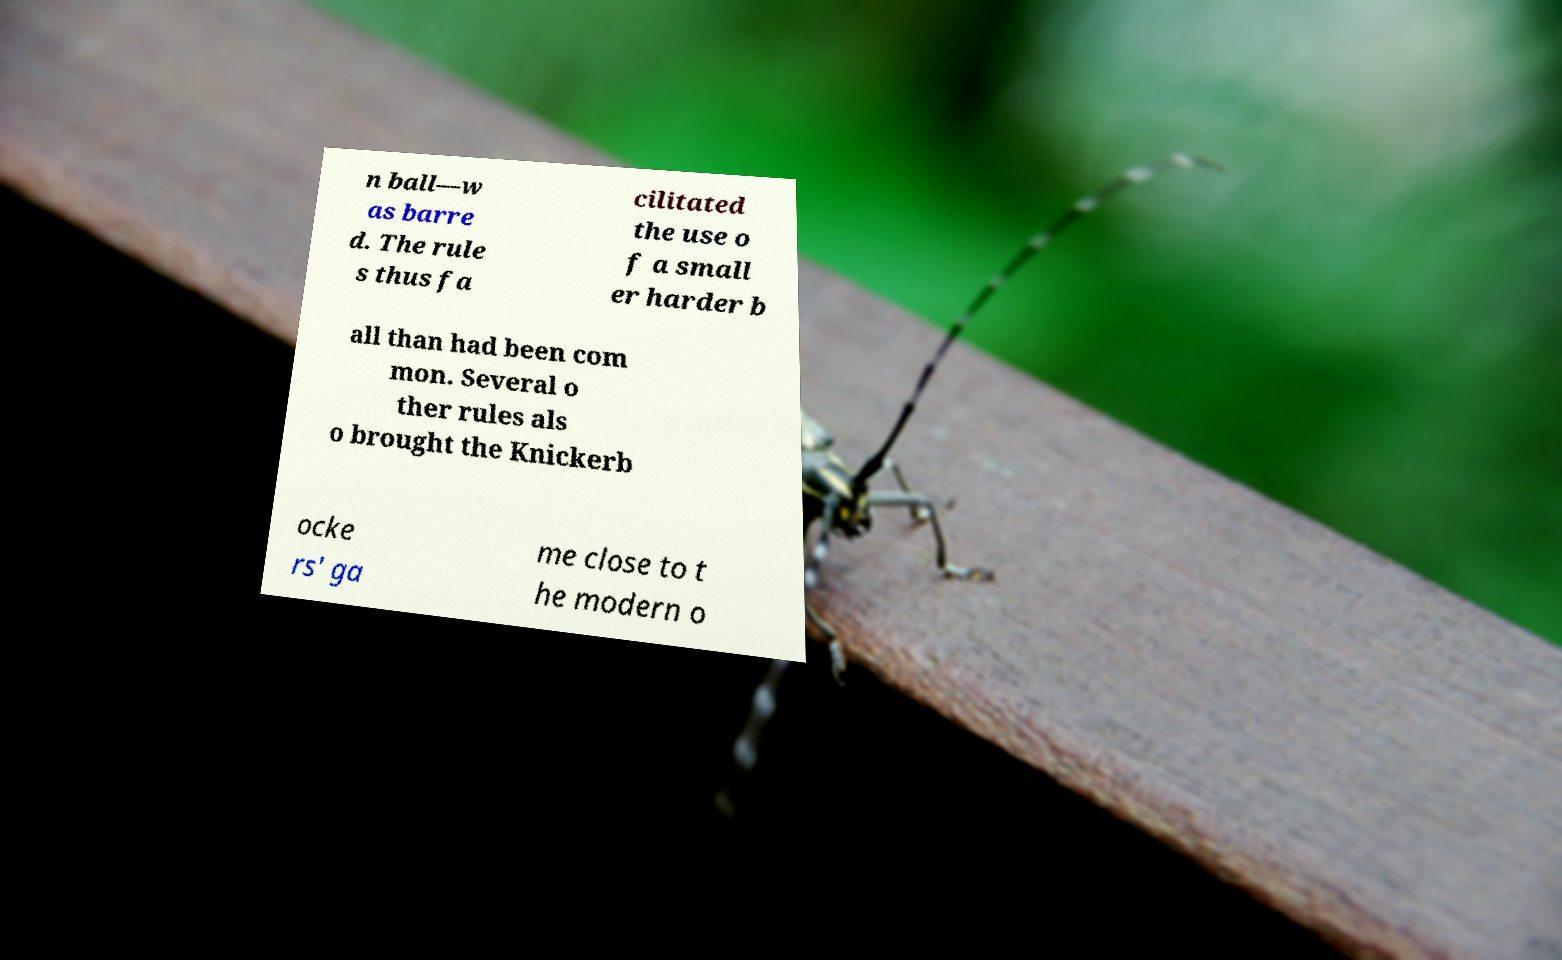Please identify and transcribe the text found in this image. n ball—w as barre d. The rule s thus fa cilitated the use o f a small er harder b all than had been com mon. Several o ther rules als o brought the Knickerb ocke rs' ga me close to t he modern o 